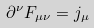Convert formula to latex. <formula><loc_0><loc_0><loc_500><loc_500>\partial ^ { \nu } F _ { \mu \nu } = j _ { \mu }</formula> 